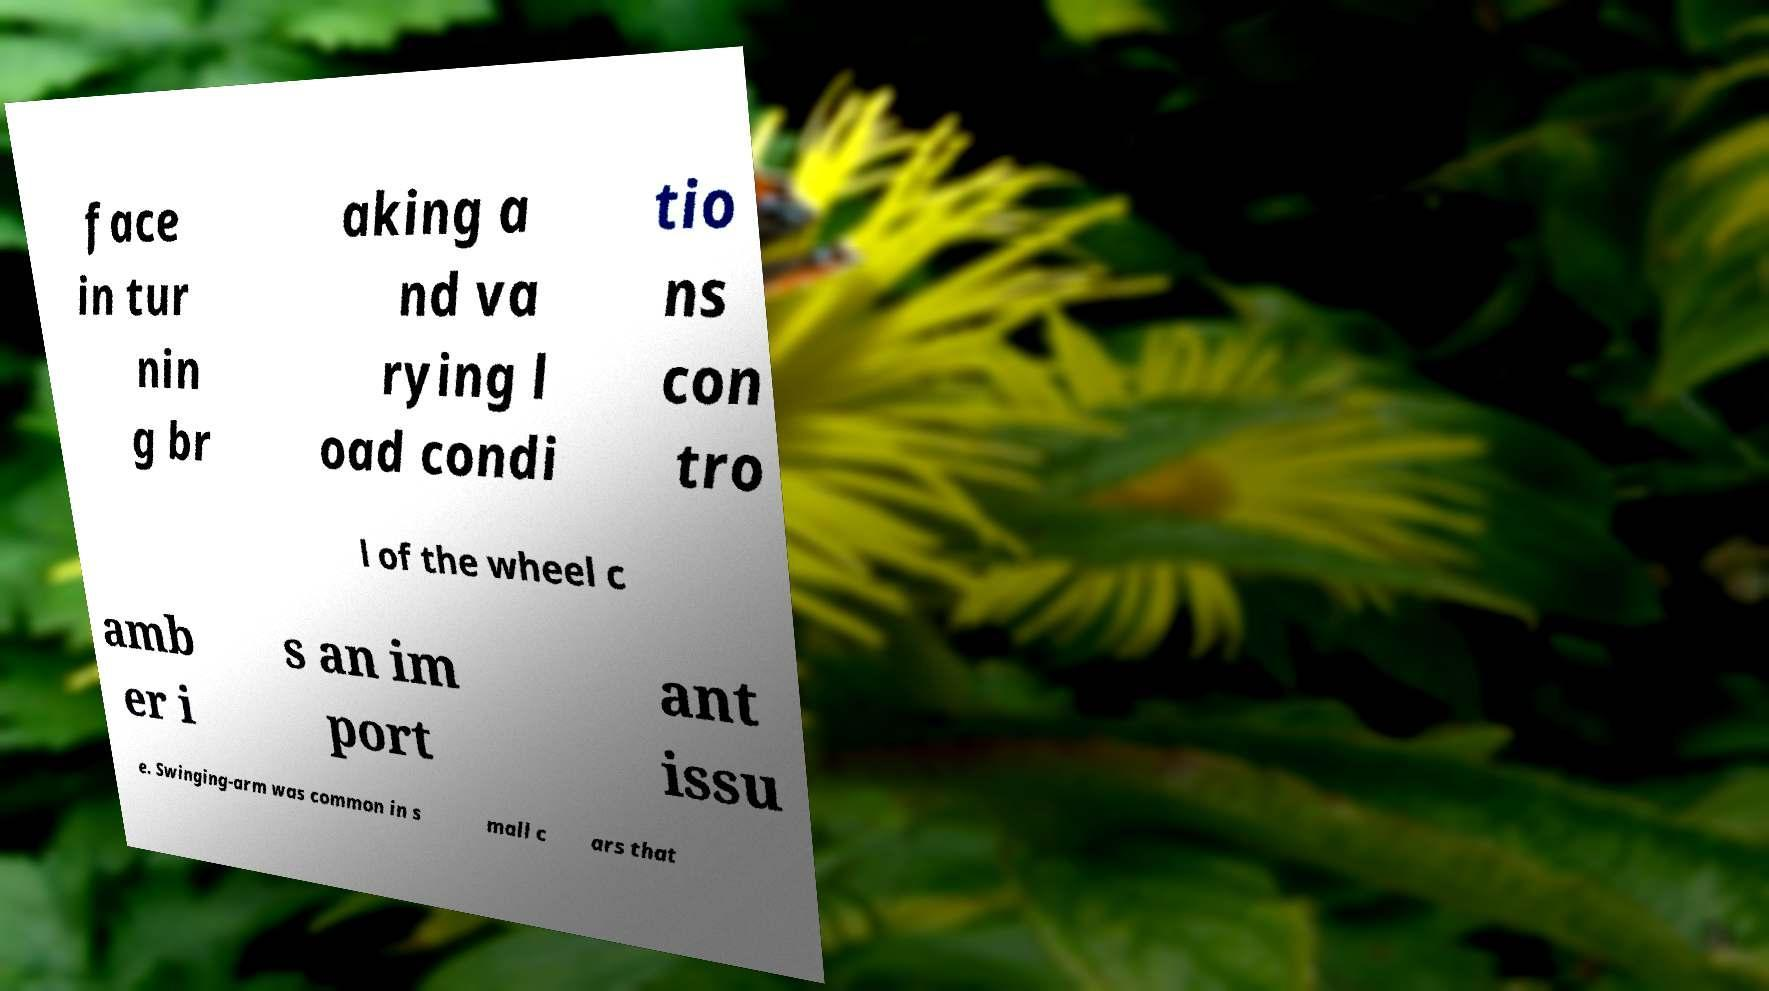Can you read and provide the text displayed in the image?This photo seems to have some interesting text. Can you extract and type it out for me? face in tur nin g br aking a nd va rying l oad condi tio ns con tro l of the wheel c amb er i s an im port ant issu e. Swinging-arm was common in s mall c ars that 